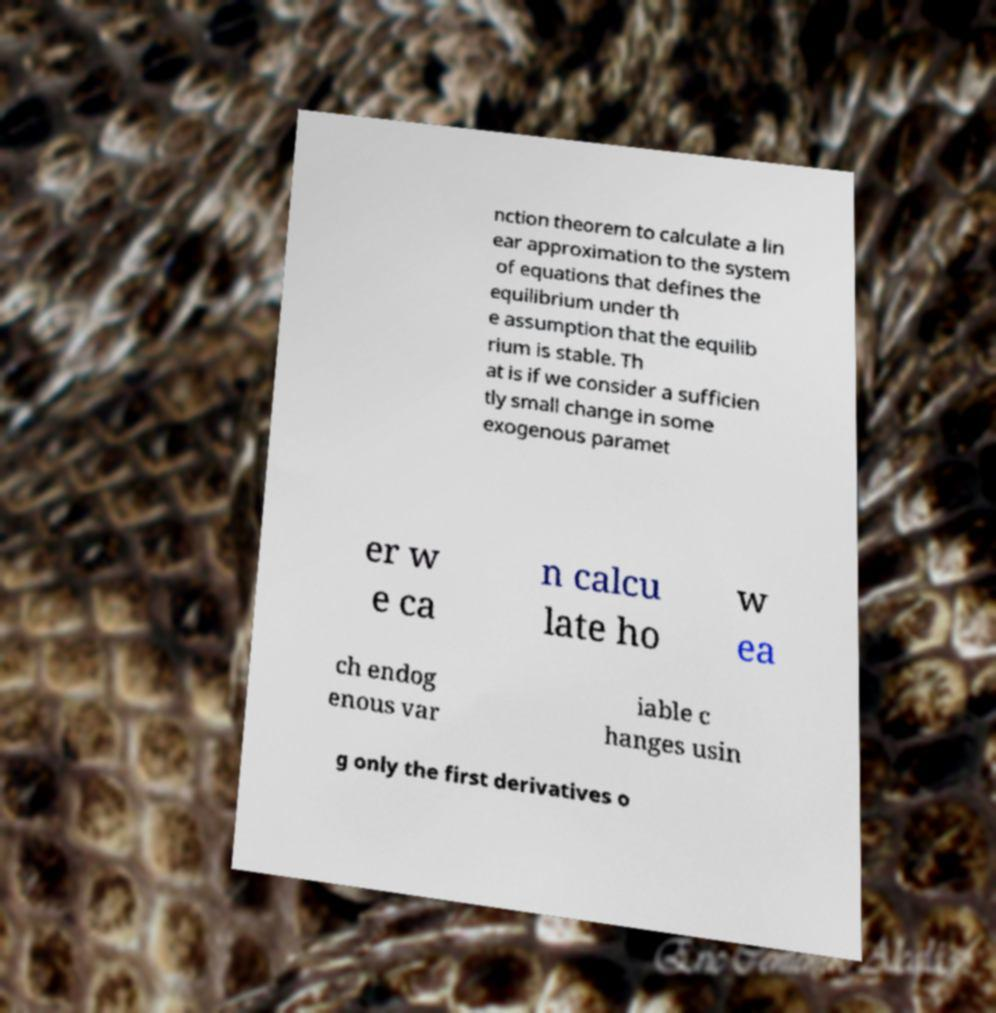There's text embedded in this image that I need extracted. Can you transcribe it verbatim? nction theorem to calculate a lin ear approximation to the system of equations that defines the equilibrium under th e assumption that the equilib rium is stable. Th at is if we consider a sufficien tly small change in some exogenous paramet er w e ca n calcu late ho w ea ch endog enous var iable c hanges usin g only the first derivatives o 